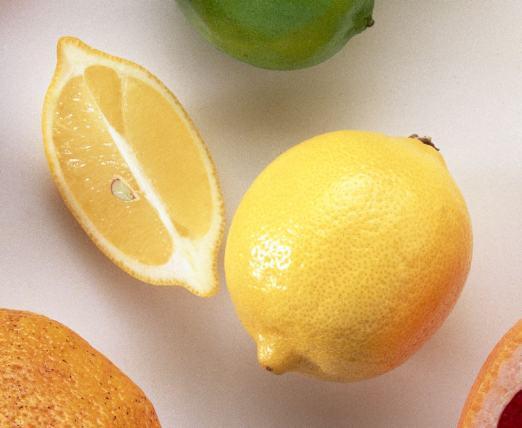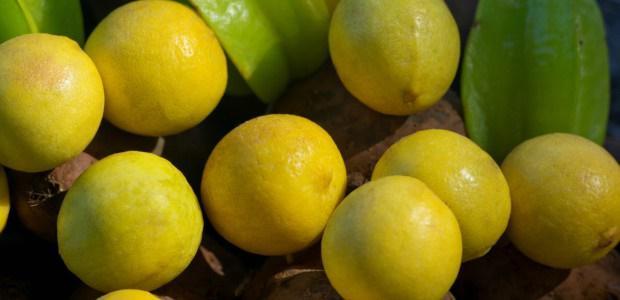The first image is the image on the left, the second image is the image on the right. For the images shown, is this caption "In at least one image there is at least one image with a full lemon and a lemon half cut horizontal." true? Answer yes or no. No. The first image is the image on the left, the second image is the image on the right. Examine the images to the left and right. Is the description "Each image includes at least one whole lemon and one half lemon." accurate? Answer yes or no. No. 